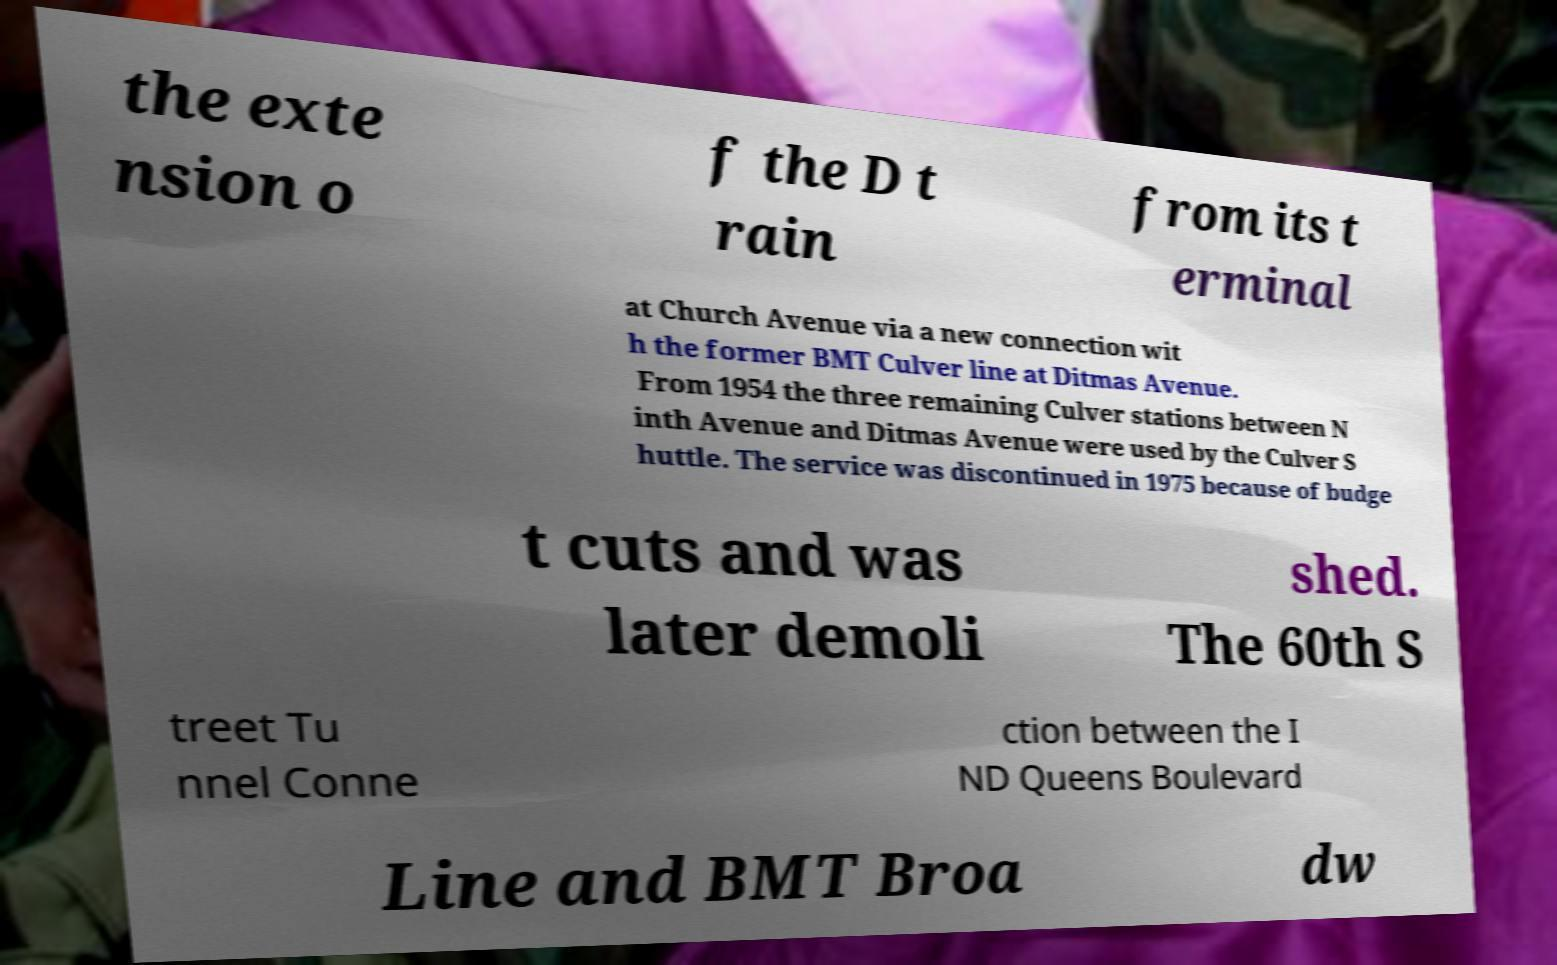Could you extract and type out the text from this image? the exte nsion o f the D t rain from its t erminal at Church Avenue via a new connection wit h the former BMT Culver line at Ditmas Avenue. From 1954 the three remaining Culver stations between N inth Avenue and Ditmas Avenue were used by the Culver S huttle. The service was discontinued in 1975 because of budge t cuts and was later demoli shed. The 60th S treet Tu nnel Conne ction between the I ND Queens Boulevard Line and BMT Broa dw 